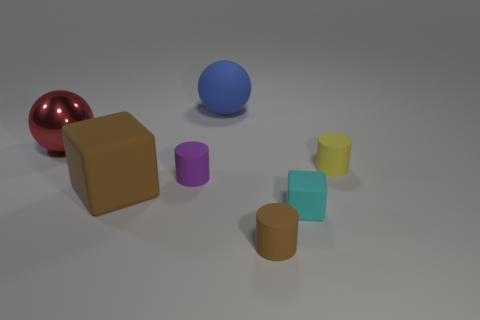Are there any other things that are the same color as the small cube?
Offer a terse response. No. How many tiny matte cylinders have the same color as the big cube?
Your answer should be very brief. 1. What shape is the brown matte object behind the small brown cylinder in front of the large brown matte cube?
Offer a very short reply. Cube. Is there another large object of the same shape as the big red shiny thing?
Keep it short and to the point. Yes. Is the color of the large block the same as the tiny cylinder in front of the purple matte thing?
Keep it short and to the point. Yes. Is there a cyan matte block that has the same size as the purple cylinder?
Your response must be concise. Yes. Is the tiny purple cylinder made of the same material as the sphere to the left of the brown cube?
Offer a very short reply. No. Is the number of tiny brown matte cylinders greater than the number of things?
Provide a short and direct response. No. What number of blocks are either large purple matte things or purple matte objects?
Ensure brevity in your answer.  0. What is the color of the tiny cube?
Give a very brief answer. Cyan. 